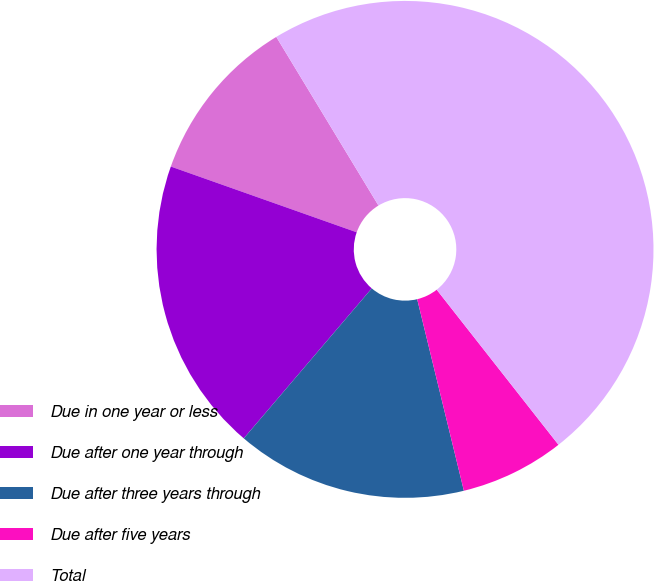Convert chart to OTSL. <chart><loc_0><loc_0><loc_500><loc_500><pie_chart><fcel>Due in one year or less<fcel>Due after one year through<fcel>Due after three years through<fcel>Due after five years<fcel>Total<nl><fcel>10.92%<fcel>19.17%<fcel>15.05%<fcel>6.79%<fcel>48.08%<nl></chart> 